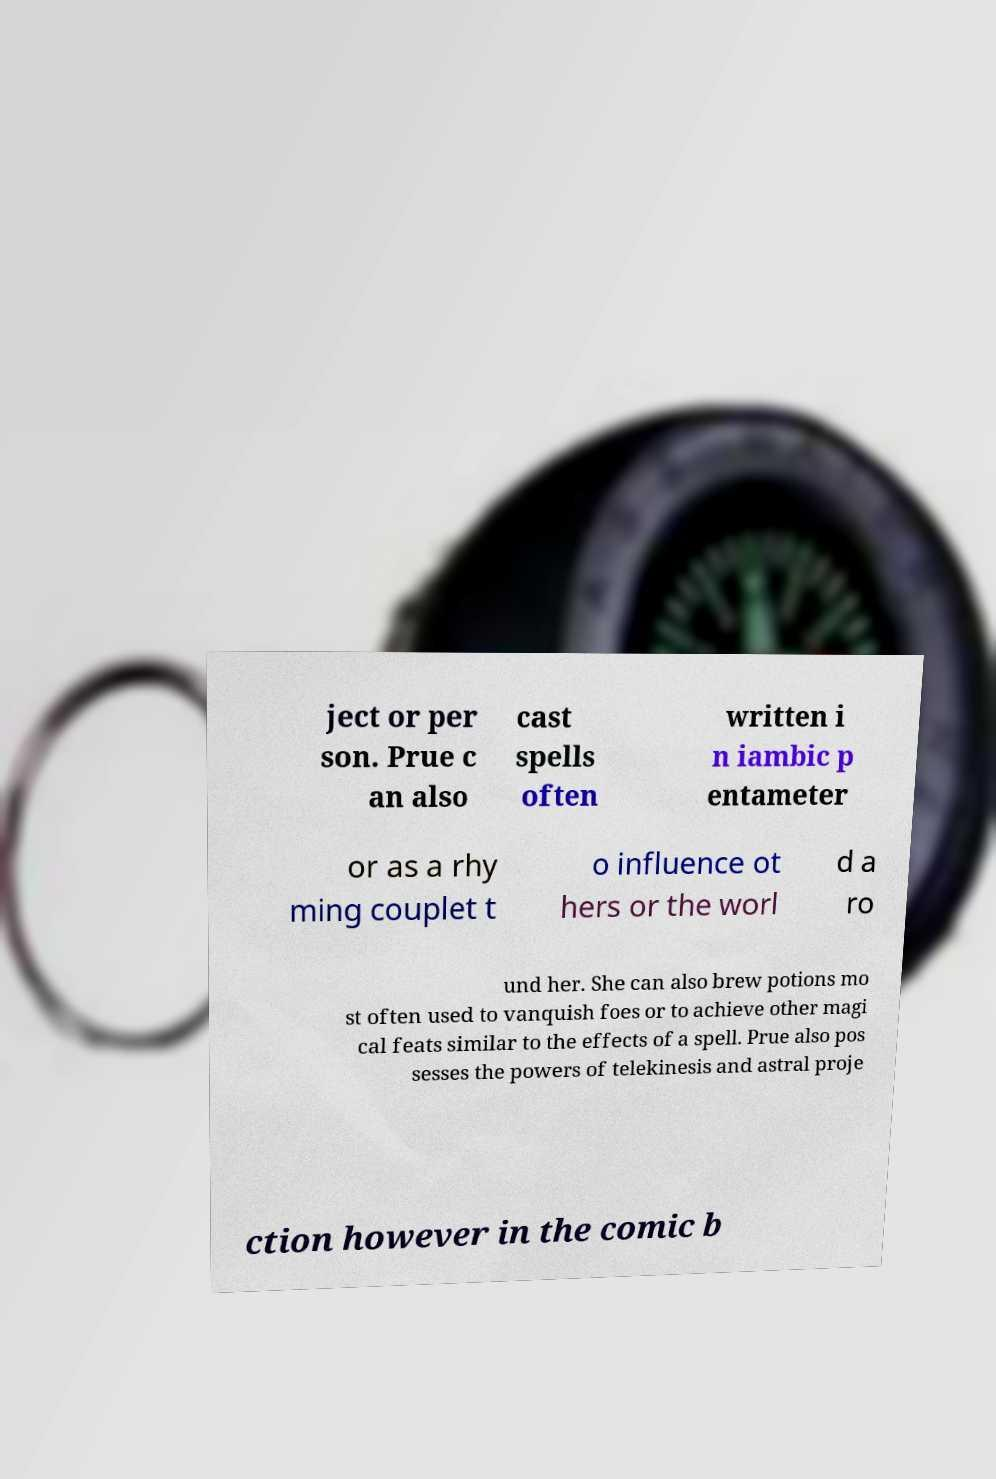Please identify and transcribe the text found in this image. ject or per son. Prue c an also cast spells often written i n iambic p entameter or as a rhy ming couplet t o influence ot hers or the worl d a ro und her. She can also brew potions mo st often used to vanquish foes or to achieve other magi cal feats similar to the effects of a spell. Prue also pos sesses the powers of telekinesis and astral proje ction however in the comic b 